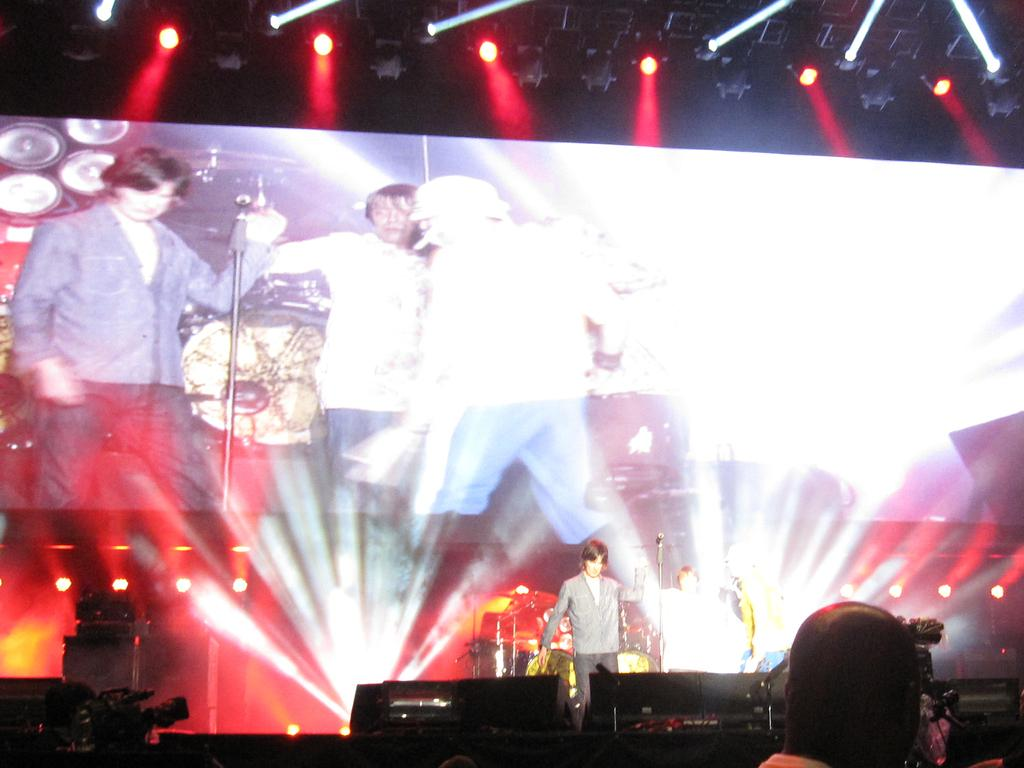What is located at the top of the image? There are lights at the top of the image. Where is the person in the image situated? There is a person sitting at the bottom of the image. What are the people in the foreground of the image doing? The people in the foreground of the image are holding objects. What can be seen in the background of the image? There is a presentation visible in the background of the image. How many kittens are playing with the chickens in the image? There are no kittens or chickens present in the image. Are there any planes visible in the image? No, there are no planes visible in the image. 